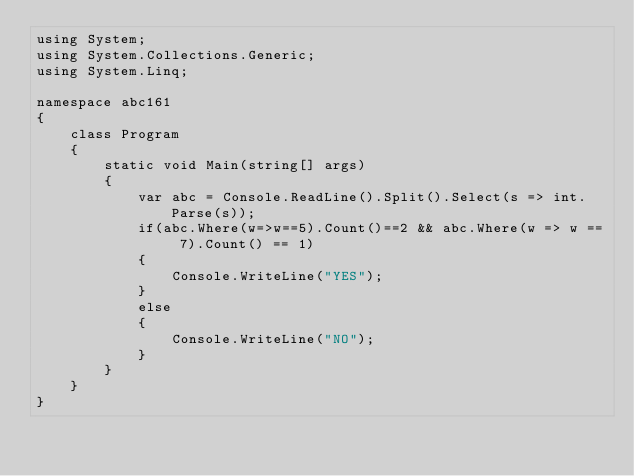<code> <loc_0><loc_0><loc_500><loc_500><_C#_>using System;
using System.Collections.Generic;
using System.Linq;

namespace abc161
{
    class Program
    {
        static void Main(string[] args)
        {
            var abc = Console.ReadLine().Split().Select(s => int.Parse(s));
            if(abc.Where(w=>w==5).Count()==2 && abc.Where(w => w == 7).Count() == 1)
            {
                Console.WriteLine("YES");
            }
            else
            {
                Console.WriteLine("NO");
            }
        }
    }
}
</code> 